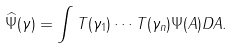Convert formula to latex. <formula><loc_0><loc_0><loc_500><loc_500>\widehat { \Psi } ( \gamma ) = \int T ( \gamma _ { 1 } ) \cdots T ( \gamma _ { n } ) \Psi ( A ) D A .</formula> 